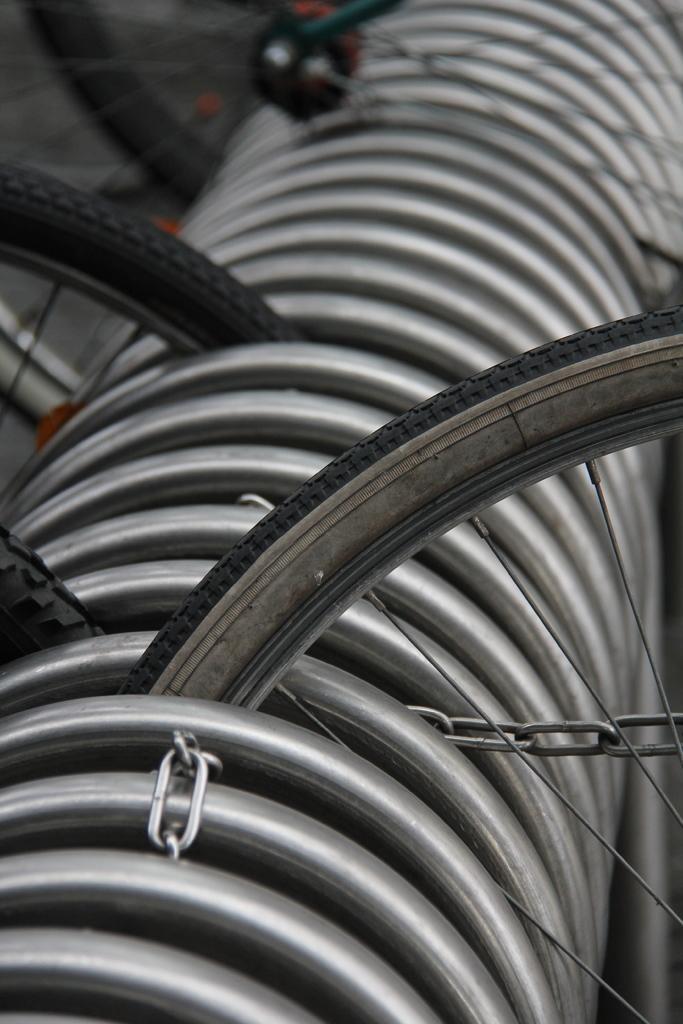Could you give a brief overview of what you see in this image? In the image we can see some bicycle wheels. 